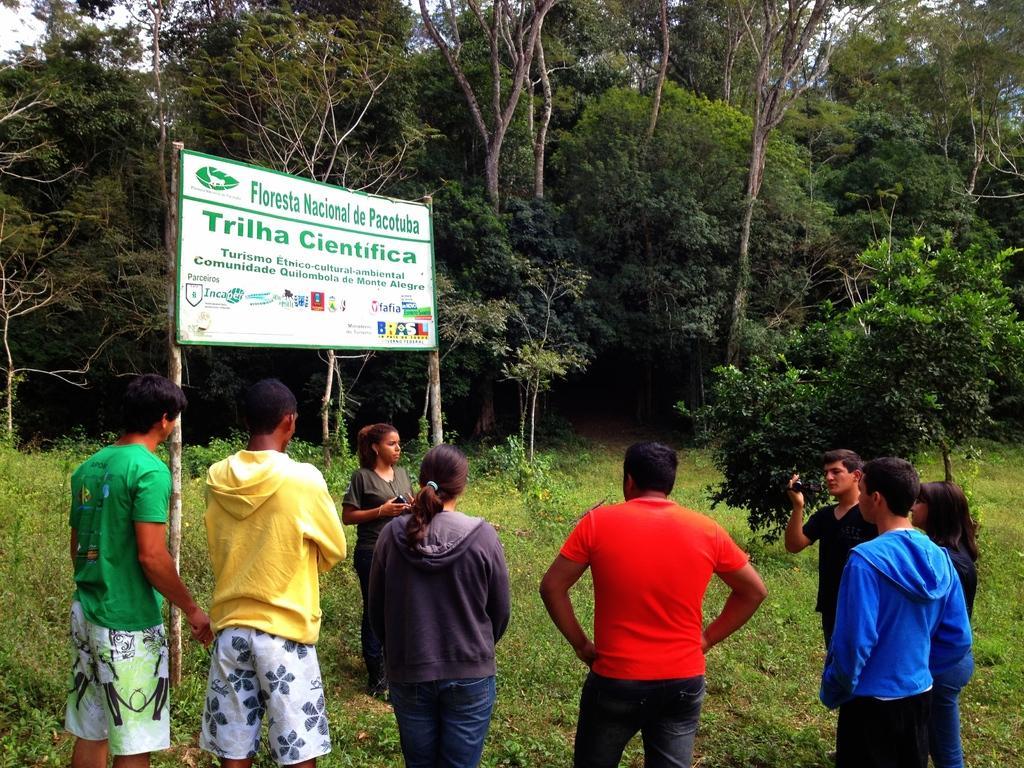Could you give a brief overview of what you see in this image? In this image I can see the group of people are standing on the ground. I can see these people are wearing the different color dresses and one person holding the camera. In the background I can see the board, many trees and the sky. 